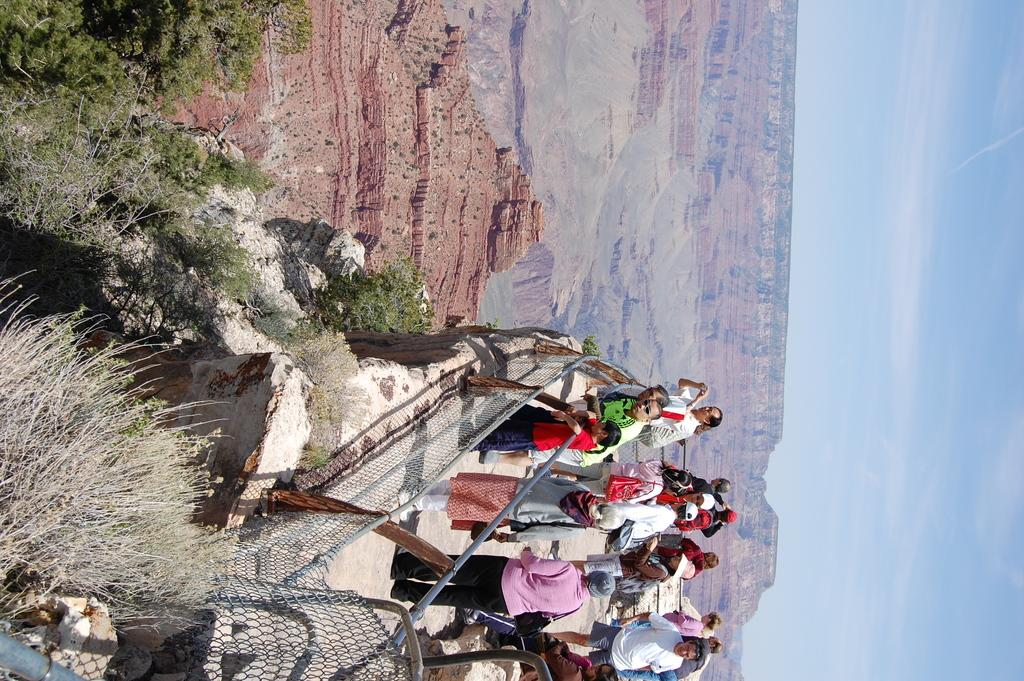What can be seen in the image? There are persons standing in the image, along with trees and a fence. What is visible in the background of the image? There are mountains in the background of the image. What type of cork can be seen in the image? There is no cork present in the image. How does the image make you feel? The image itself does not evoke emotions, as it is a static representation of a scene. 